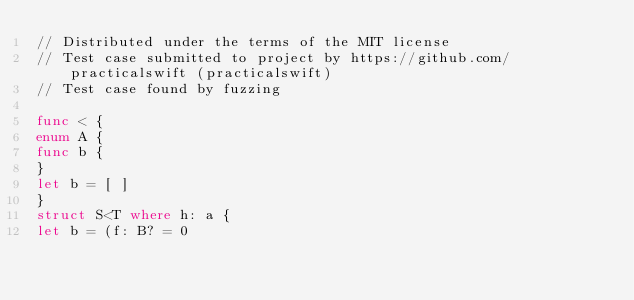Convert code to text. <code><loc_0><loc_0><loc_500><loc_500><_Swift_>// Distributed under the terms of the MIT license
// Test case submitted to project by https://github.com/practicalswift (practicalswift)
// Test case found by fuzzing

func < {
enum A {
func b {
}
let b = [ ]
}
struct S<T where h: a {
let b = (f: B? = 0
</code> 